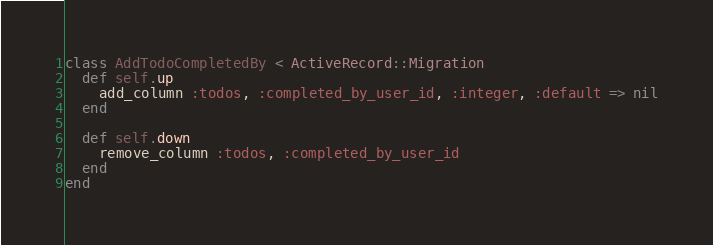<code> <loc_0><loc_0><loc_500><loc_500><_Ruby_>class AddTodoCompletedBy < ActiveRecord::Migration
  def self.up
    add_column :todos, :completed_by_user_id, :integer, :default => nil
  end

  def self.down
    remove_column :todos, :completed_by_user_id
  end
end
</code> 